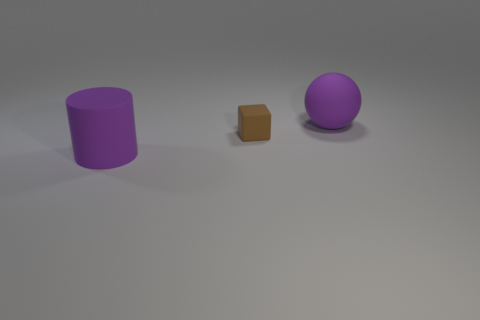Add 2 matte cylinders. How many objects exist? 5 Subtract all big balls. Subtract all tiny cyan shiny objects. How many objects are left? 2 Add 2 big purple cylinders. How many big purple cylinders are left? 3 Add 1 yellow metallic spheres. How many yellow metallic spheres exist? 1 Subtract 0 green balls. How many objects are left? 3 Subtract all cylinders. How many objects are left? 2 